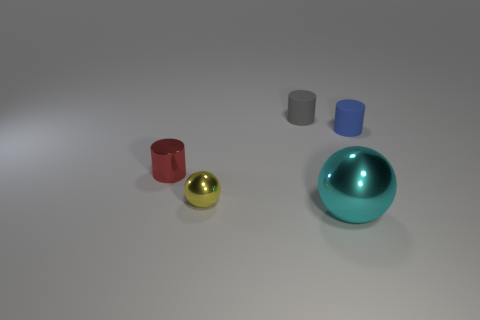Add 2 large matte balls. How many objects exist? 7 Subtract all red cylinders. How many cylinders are left? 2 Subtract all balls. How many objects are left? 3 Subtract all small metallic cylinders. How many cylinders are left? 2 Subtract 3 cylinders. How many cylinders are left? 0 Subtract all brown cylinders. How many yellow spheres are left? 1 Add 5 small cyan metal cubes. How many small cyan metal cubes exist? 5 Subtract 1 yellow spheres. How many objects are left? 4 Subtract all purple cylinders. Subtract all purple balls. How many cylinders are left? 3 Subtract all large brown spheres. Subtract all big spheres. How many objects are left? 4 